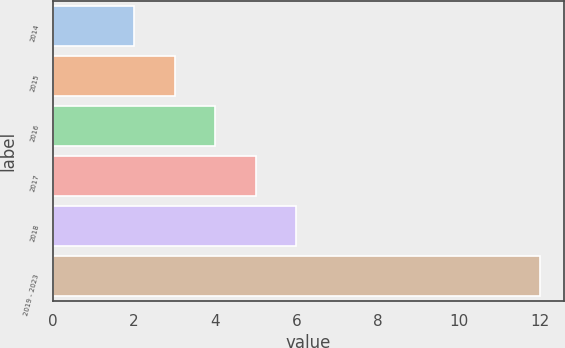Convert chart to OTSL. <chart><loc_0><loc_0><loc_500><loc_500><bar_chart><fcel>2014<fcel>2015<fcel>2016<fcel>2017<fcel>2018<fcel>2019 - 2023<nl><fcel>2<fcel>3<fcel>4<fcel>5<fcel>6<fcel>12<nl></chart> 